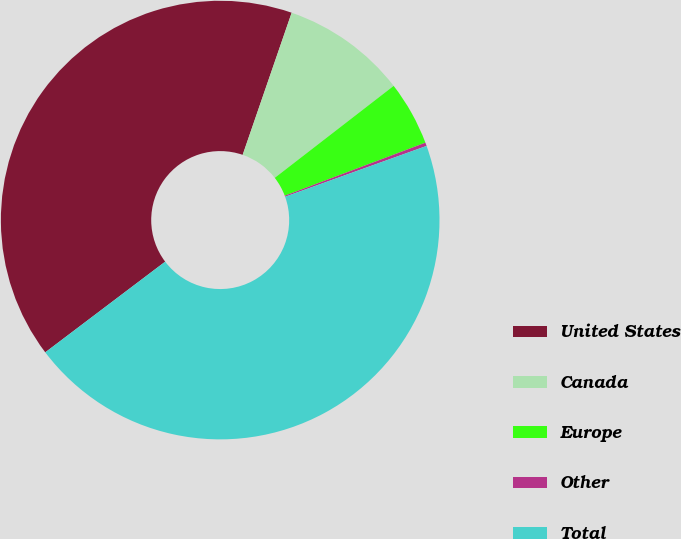Convert chart to OTSL. <chart><loc_0><loc_0><loc_500><loc_500><pie_chart><fcel>United States<fcel>Canada<fcel>Europe<fcel>Other<fcel>Total<nl><fcel>40.59%<fcel>9.24%<fcel>4.74%<fcel>0.25%<fcel>45.19%<nl></chart> 